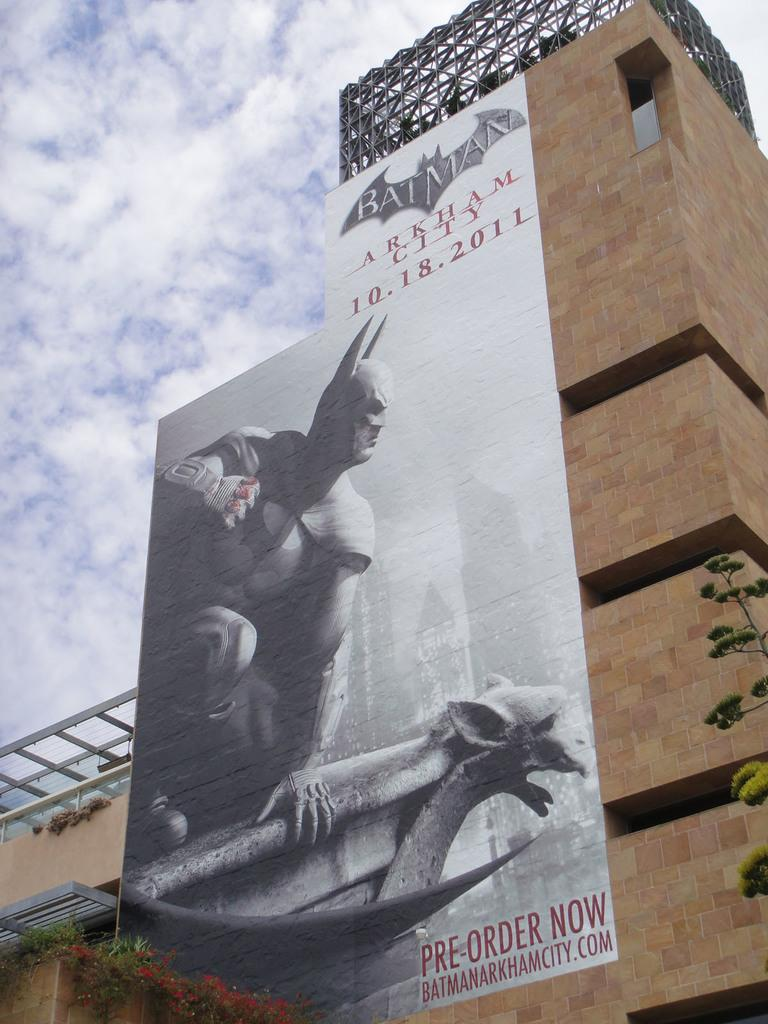<image>
Share a concise interpretation of the image provided. A Batman advertisement to order it now, coming out 10.18.2011. 